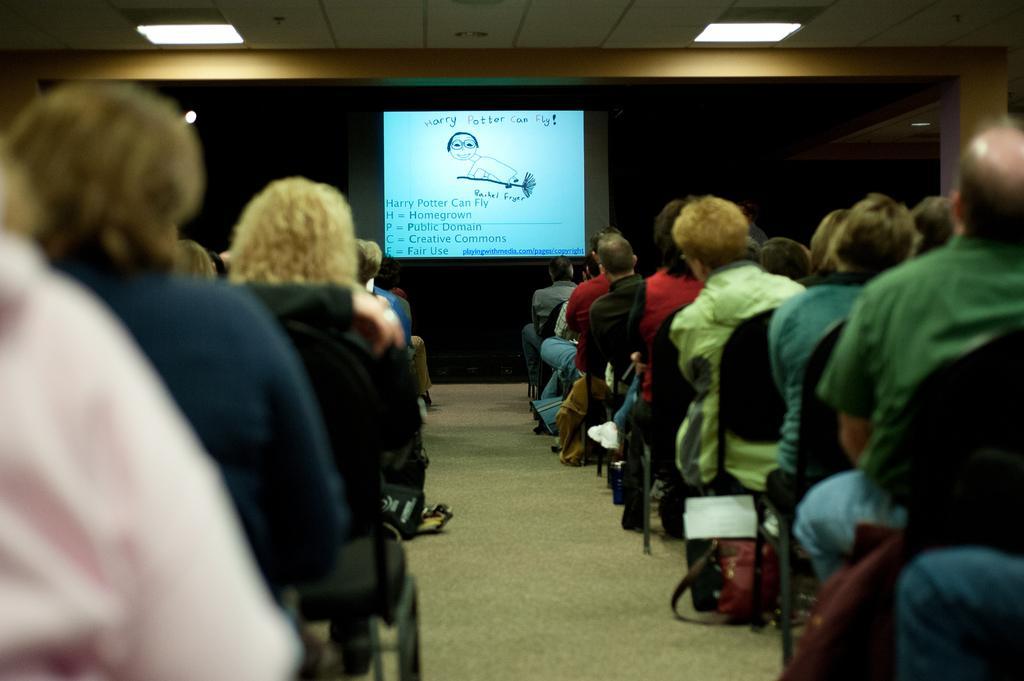Could you give a brief overview of what you see in this image? In this picture we can see people are sitting on chairs. On carpet there are bags. In the background there are ceiling lights and screen along with image and text. 